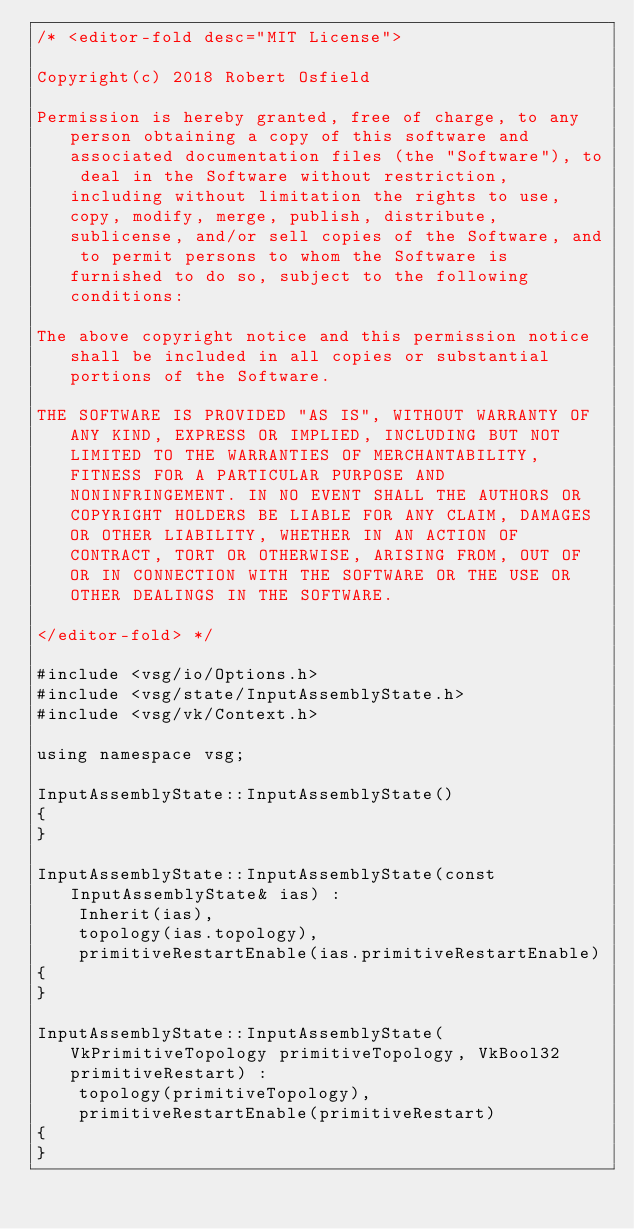<code> <loc_0><loc_0><loc_500><loc_500><_C++_>/* <editor-fold desc="MIT License">

Copyright(c) 2018 Robert Osfield

Permission is hereby granted, free of charge, to any person obtaining a copy of this software and associated documentation files (the "Software"), to deal in the Software without restriction, including without limitation the rights to use, copy, modify, merge, publish, distribute, sublicense, and/or sell copies of the Software, and to permit persons to whom the Software is furnished to do so, subject to the following conditions:

The above copyright notice and this permission notice shall be included in all copies or substantial portions of the Software.

THE SOFTWARE IS PROVIDED "AS IS", WITHOUT WARRANTY OF ANY KIND, EXPRESS OR IMPLIED, INCLUDING BUT NOT LIMITED TO THE WARRANTIES OF MERCHANTABILITY, FITNESS FOR A PARTICULAR PURPOSE AND NONINFRINGEMENT. IN NO EVENT SHALL THE AUTHORS OR COPYRIGHT HOLDERS BE LIABLE FOR ANY CLAIM, DAMAGES OR OTHER LIABILITY, WHETHER IN AN ACTION OF CONTRACT, TORT OR OTHERWISE, ARISING FROM, OUT OF OR IN CONNECTION WITH THE SOFTWARE OR THE USE OR OTHER DEALINGS IN THE SOFTWARE.

</editor-fold> */

#include <vsg/io/Options.h>
#include <vsg/state/InputAssemblyState.h>
#include <vsg/vk/Context.h>

using namespace vsg;

InputAssemblyState::InputAssemblyState()
{
}

InputAssemblyState::InputAssemblyState(const InputAssemblyState& ias) :
    Inherit(ias),
    topology(ias.topology),
    primitiveRestartEnable(ias.primitiveRestartEnable)
{
}

InputAssemblyState::InputAssemblyState(VkPrimitiveTopology primitiveTopology, VkBool32 primitiveRestart) :
    topology(primitiveTopology),
    primitiveRestartEnable(primitiveRestart)
{
}
</code> 